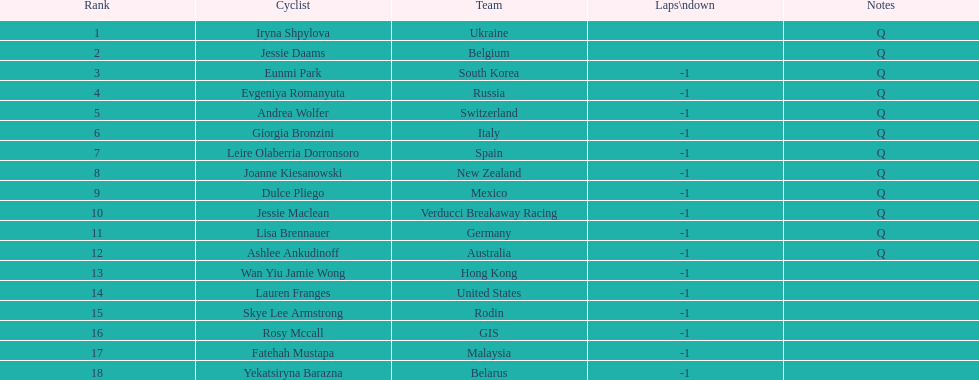Who is the final bicycle rider mentioned? Yekatsiryna Barazna. 